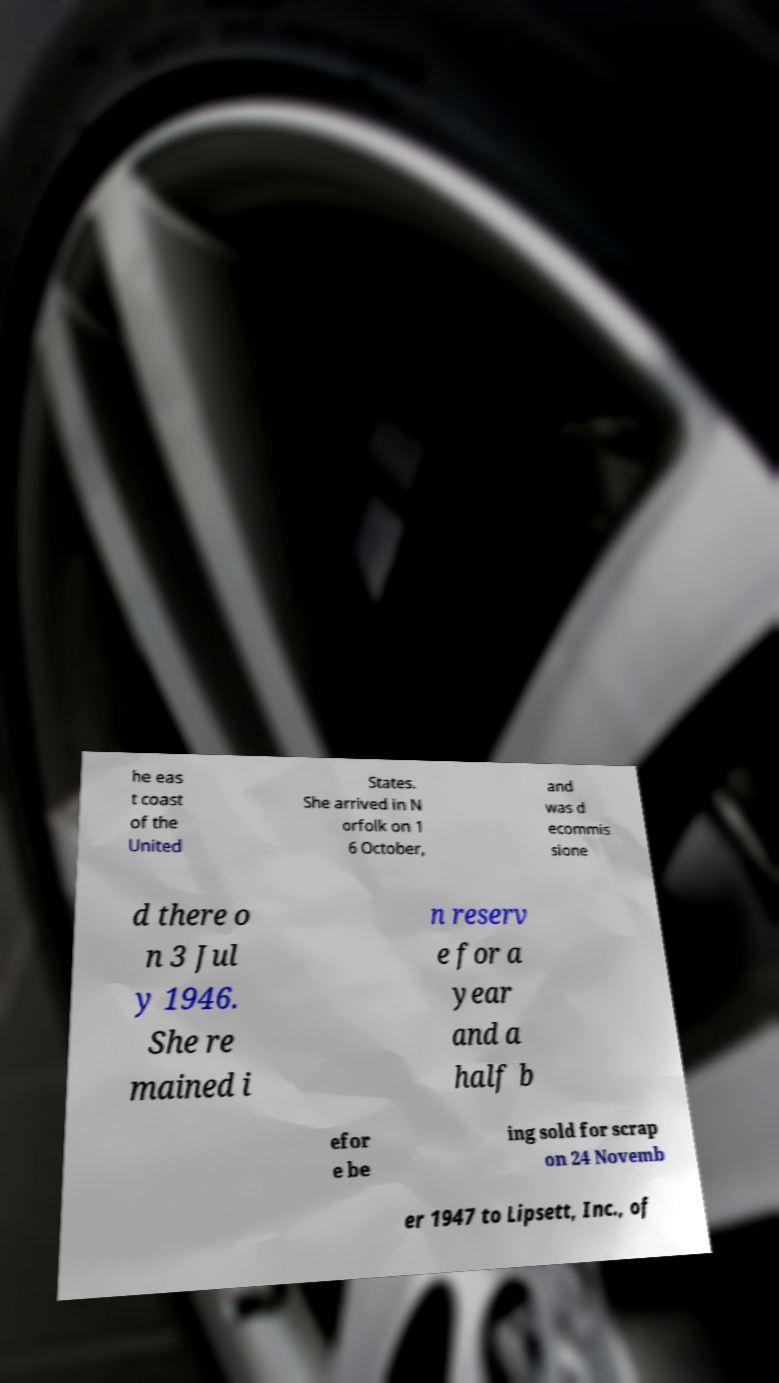There's text embedded in this image that I need extracted. Can you transcribe it verbatim? he eas t coast of the United States. She arrived in N orfolk on 1 6 October, and was d ecommis sione d there o n 3 Jul y 1946. She re mained i n reserv e for a year and a half b efor e be ing sold for scrap on 24 Novemb er 1947 to Lipsett, Inc., of 